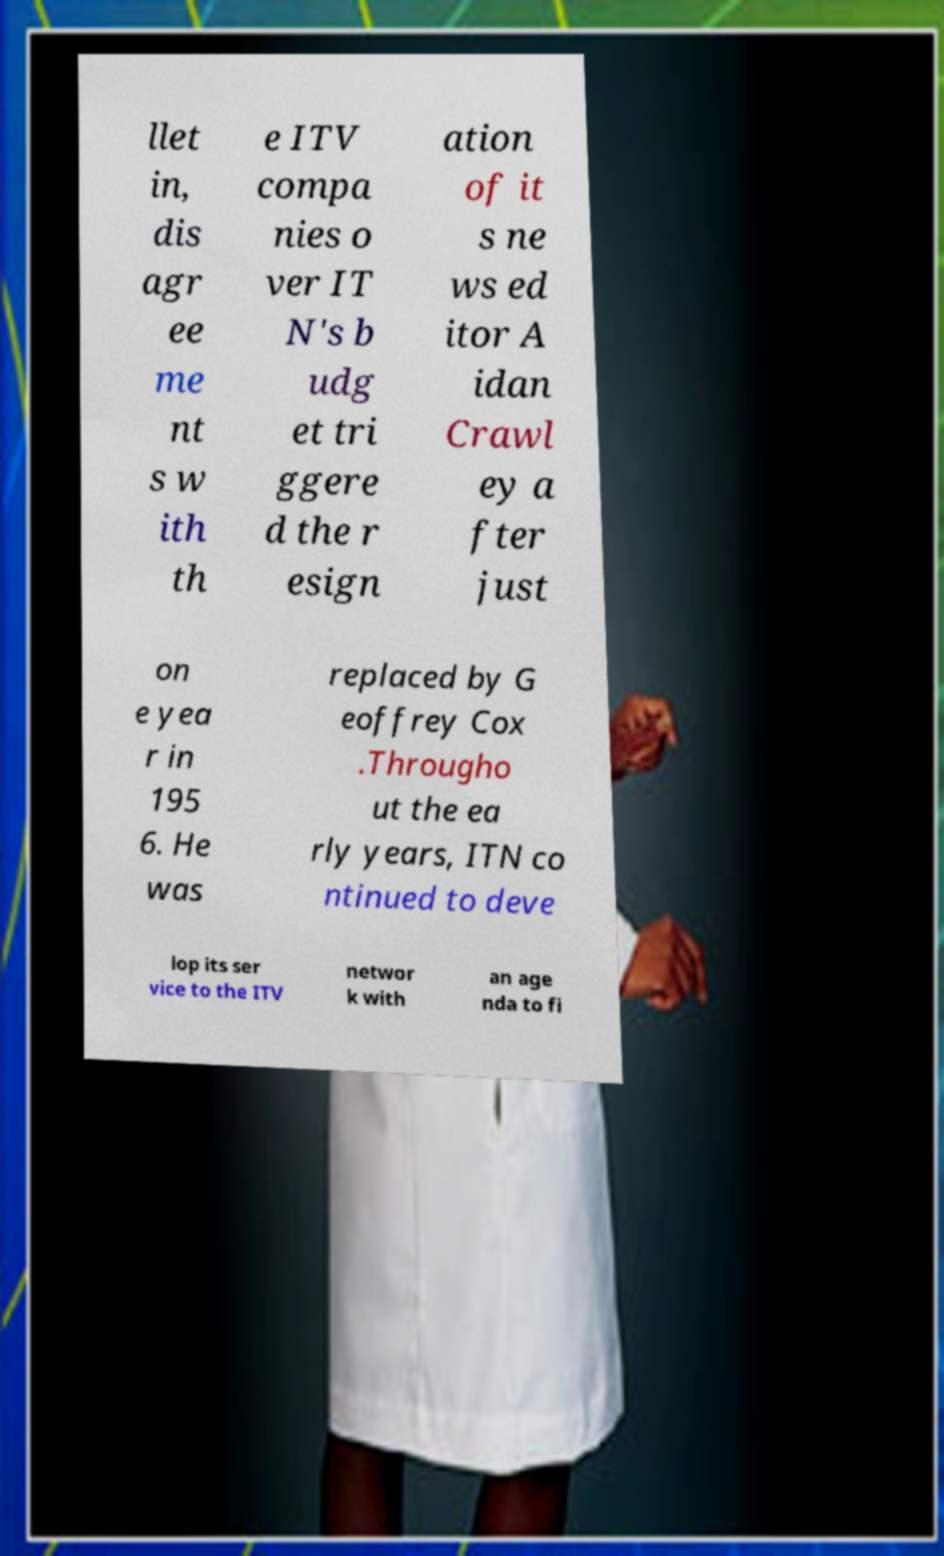Could you extract and type out the text from this image? llet in, dis agr ee me nt s w ith th e ITV compa nies o ver IT N's b udg et tri ggere d the r esign ation of it s ne ws ed itor A idan Crawl ey a fter just on e yea r in 195 6. He was replaced by G eoffrey Cox .Througho ut the ea rly years, ITN co ntinued to deve lop its ser vice to the ITV networ k with an age nda to fi 